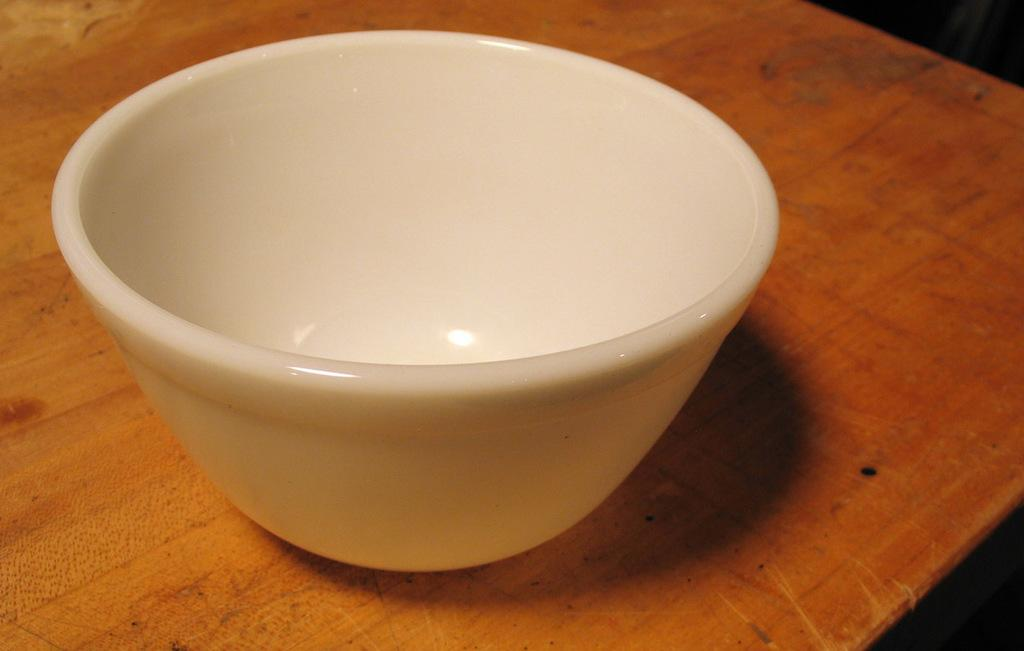Where was the image taken? The image was taken indoors. What furniture is visible in the image? There is a table in the image. What is on the table in the image? There is a bowl on the table. What type of chin can be seen on the bowl in the image? There is no chin present in the image, as it is a bowl and not a person. 